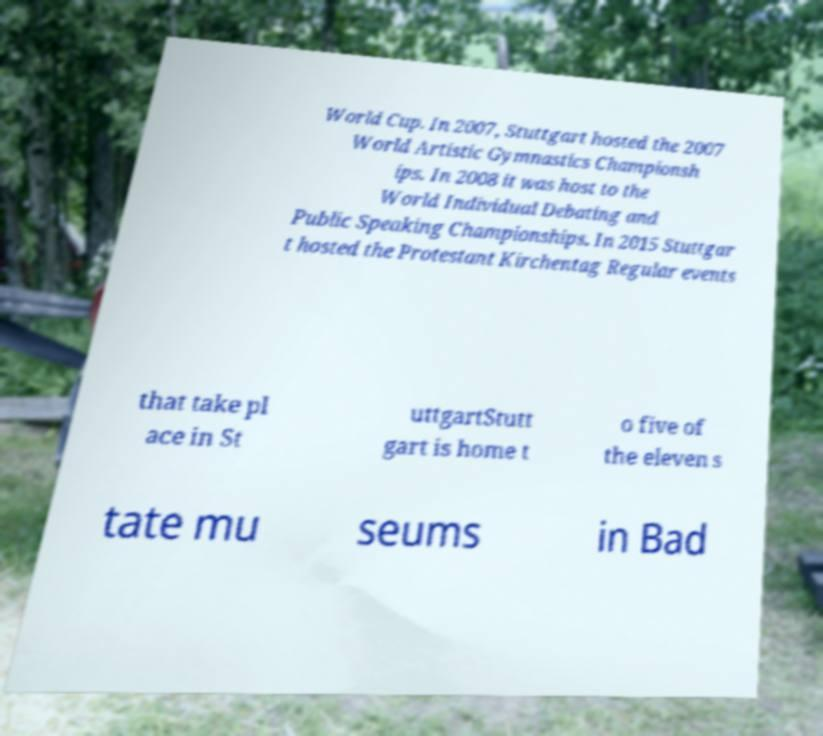There's text embedded in this image that I need extracted. Can you transcribe it verbatim? World Cup. In 2007, Stuttgart hosted the 2007 World Artistic Gymnastics Championsh ips. In 2008 it was host to the World Individual Debating and Public Speaking Championships. In 2015 Stuttgar t hosted the Protestant Kirchentag Regular events that take pl ace in St uttgartStutt gart is home t o five of the eleven s tate mu seums in Bad 